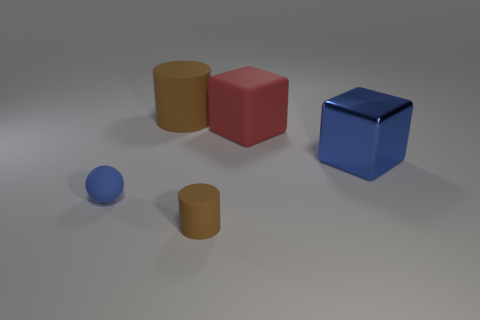Subtract all red cubes. How many cubes are left? 1 Add 2 red blocks. How many objects exist? 7 Subtract all cubes. How many objects are left? 3 Subtract 0 cyan spheres. How many objects are left? 5 Subtract all tiny red rubber blocks. Subtract all large blue metallic objects. How many objects are left? 4 Add 2 large rubber blocks. How many large rubber blocks are left? 3 Add 3 shiny objects. How many shiny objects exist? 4 